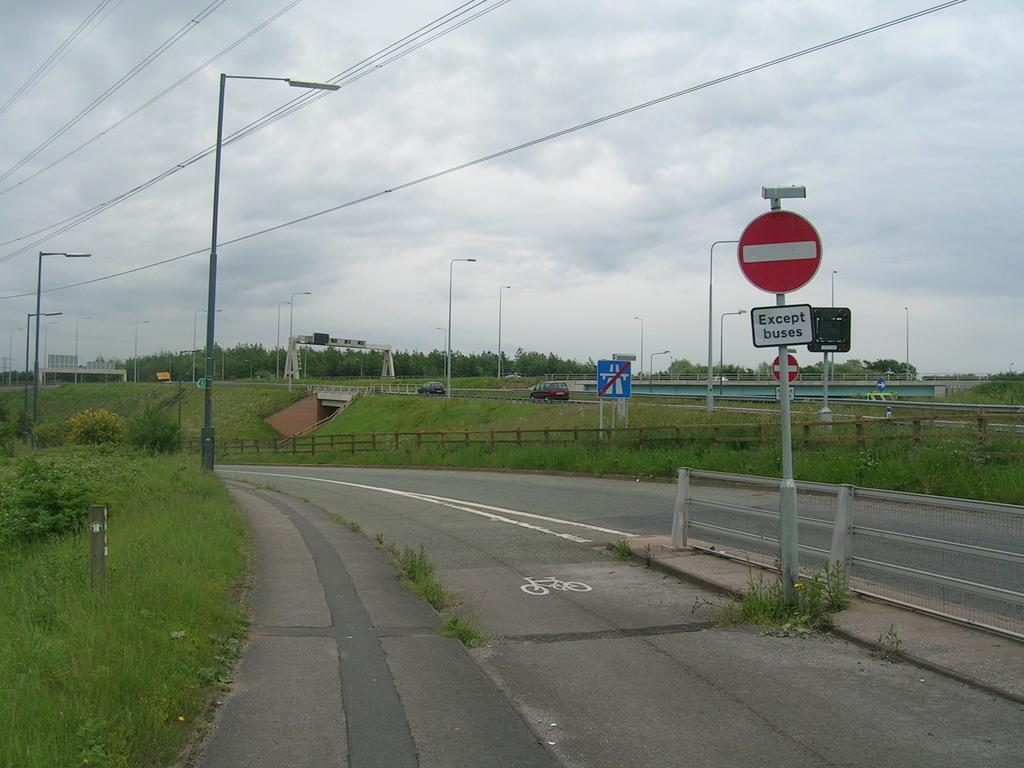<image>
Offer a succinct explanation of the picture presented. A road sign with Except Buses written on it. 